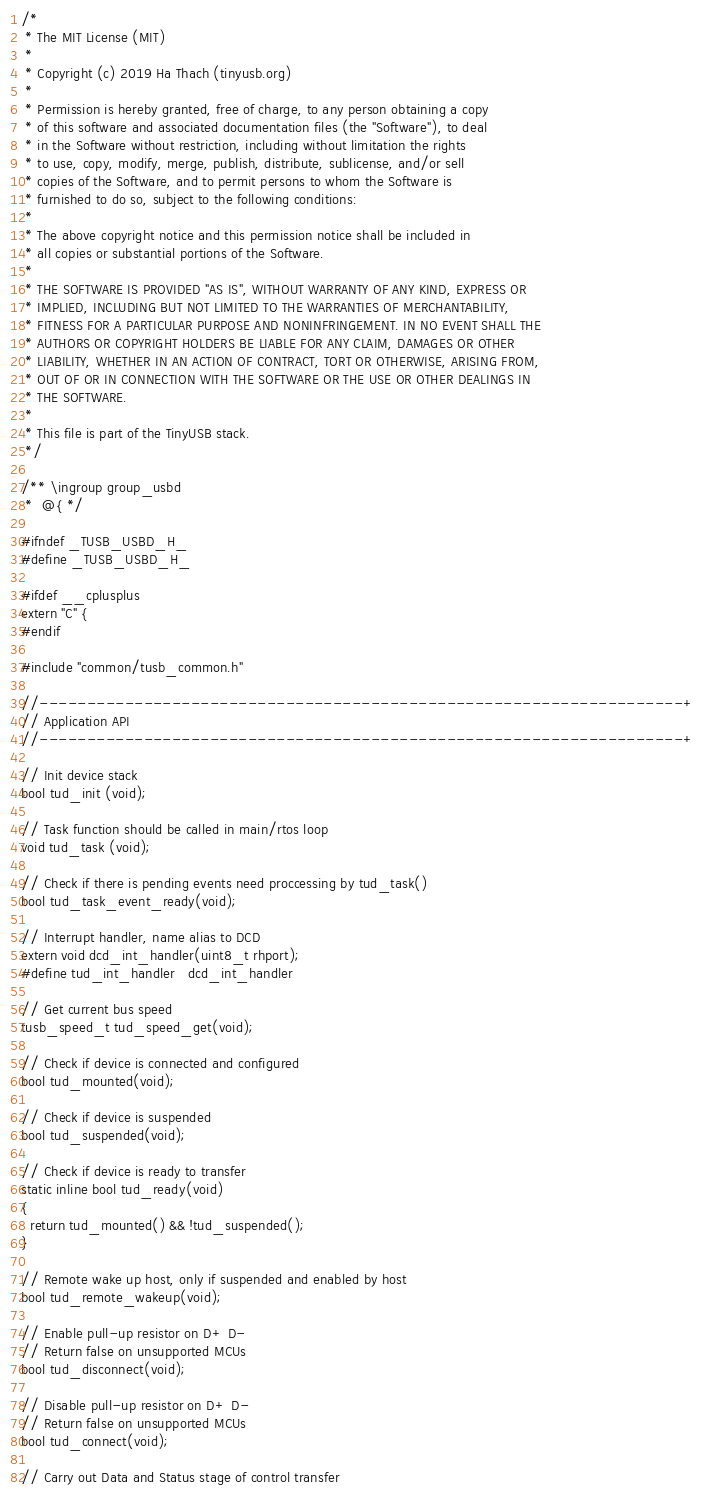<code> <loc_0><loc_0><loc_500><loc_500><_C_>/* 
 * The MIT License (MIT)
 *
 * Copyright (c) 2019 Ha Thach (tinyusb.org)
 *
 * Permission is hereby granted, free of charge, to any person obtaining a copy
 * of this software and associated documentation files (the "Software"), to deal
 * in the Software without restriction, including without limitation the rights
 * to use, copy, modify, merge, publish, distribute, sublicense, and/or sell
 * copies of the Software, and to permit persons to whom the Software is
 * furnished to do so, subject to the following conditions:
 *
 * The above copyright notice and this permission notice shall be included in
 * all copies or substantial portions of the Software.
 *
 * THE SOFTWARE IS PROVIDED "AS IS", WITHOUT WARRANTY OF ANY KIND, EXPRESS OR
 * IMPLIED, INCLUDING BUT NOT LIMITED TO THE WARRANTIES OF MERCHANTABILITY,
 * FITNESS FOR A PARTICULAR PURPOSE AND NONINFRINGEMENT. IN NO EVENT SHALL THE
 * AUTHORS OR COPYRIGHT HOLDERS BE LIABLE FOR ANY CLAIM, DAMAGES OR OTHER
 * LIABILITY, WHETHER IN AN ACTION OF CONTRACT, TORT OR OTHERWISE, ARISING FROM,
 * OUT OF OR IN CONNECTION WITH THE SOFTWARE OR THE USE OR OTHER DEALINGS IN
 * THE SOFTWARE.
 *
 * This file is part of the TinyUSB stack.
 */

/** \ingroup group_usbd
 *  @{ */

#ifndef _TUSB_USBD_H_
#define _TUSB_USBD_H_

#ifdef __cplusplus
extern "C" {
#endif

#include "common/tusb_common.h"

//--------------------------------------------------------------------+
// Application API
//--------------------------------------------------------------------+

// Init device stack
bool tud_init (void);

// Task function should be called in main/rtos loop
void tud_task (void);

// Check if there is pending events need proccessing by tud_task()
bool tud_task_event_ready(void);

// Interrupt handler, name alias to DCD
extern void dcd_int_handler(uint8_t rhport);
#define tud_int_handler   dcd_int_handler

// Get current bus speed
tusb_speed_t tud_speed_get(void);

// Check if device is connected and configured
bool tud_mounted(void);

// Check if device is suspended
bool tud_suspended(void);

// Check if device is ready to transfer
static inline bool tud_ready(void)
{
  return tud_mounted() && !tud_suspended();
}

// Remote wake up host, only if suspended and enabled by host
bool tud_remote_wakeup(void);

// Enable pull-up resistor on D+ D-
// Return false on unsupported MCUs
bool tud_disconnect(void);

// Disable pull-up resistor on D+ D-
// Return false on unsupported MCUs
bool tud_connect(void);

// Carry out Data and Status stage of control transfer</code> 